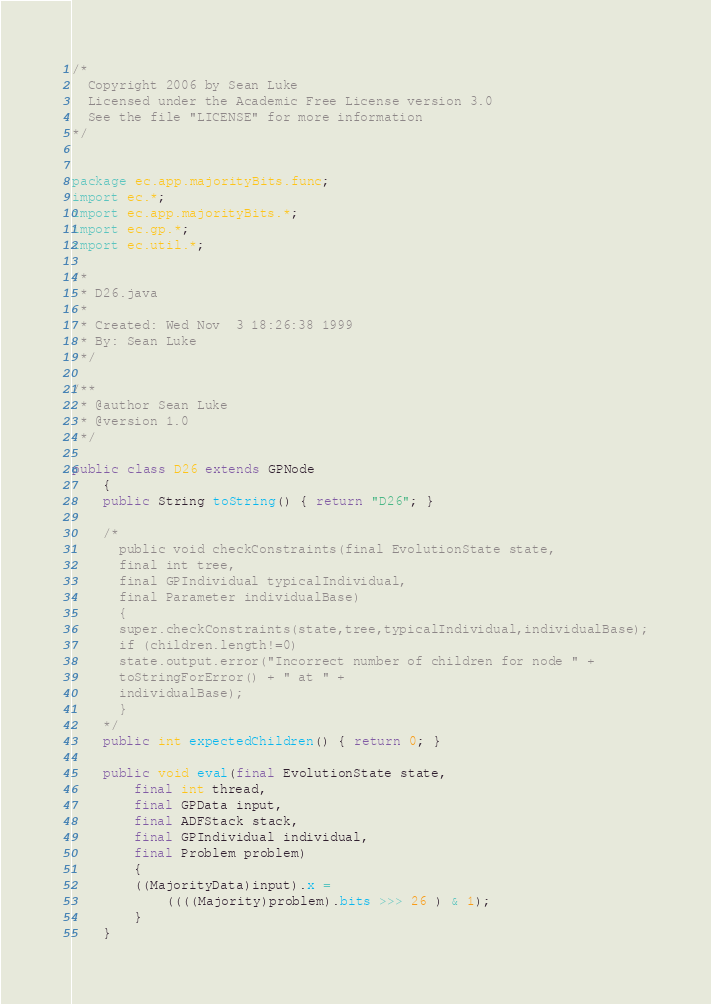<code> <loc_0><loc_0><loc_500><loc_500><_Java_>/*
  Copyright 2006 by Sean Luke
  Licensed under the Academic Free License version 3.0
  See the file "LICENSE" for more information
*/


package ec.app.majorityBits.func;
import ec.*;
import ec.app.majorityBits.*;
import ec.gp.*;
import ec.util.*;

/* 
 * D26.java
 * 
 * Created: Wed Nov  3 18:26:38 1999
 * By: Sean Luke
 */

/**
 * @author Sean Luke
 * @version 1.0 
 */

public class D26 extends GPNode
    {
    public String toString() { return "D26"; }

    /*
      public void checkConstraints(final EvolutionState state,
      final int tree,
      final GPIndividual typicalIndividual,
      final Parameter individualBase)
      {
      super.checkConstraints(state,tree,typicalIndividual,individualBase);
      if (children.length!=0)
      state.output.error("Incorrect number of children for node " + 
      toStringForError() + " at " +
      individualBase);
      }
    */
    public int expectedChildren() { return 0; }

    public void eval(final EvolutionState state,
        final int thread,
        final GPData input,
        final ADFStack stack,
        final GPIndividual individual,
        final Problem problem)
        {
        ((MajorityData)input).x = 
            ((((Majority)problem).bits >>> 26 ) & 1);
        }
    }



</code> 